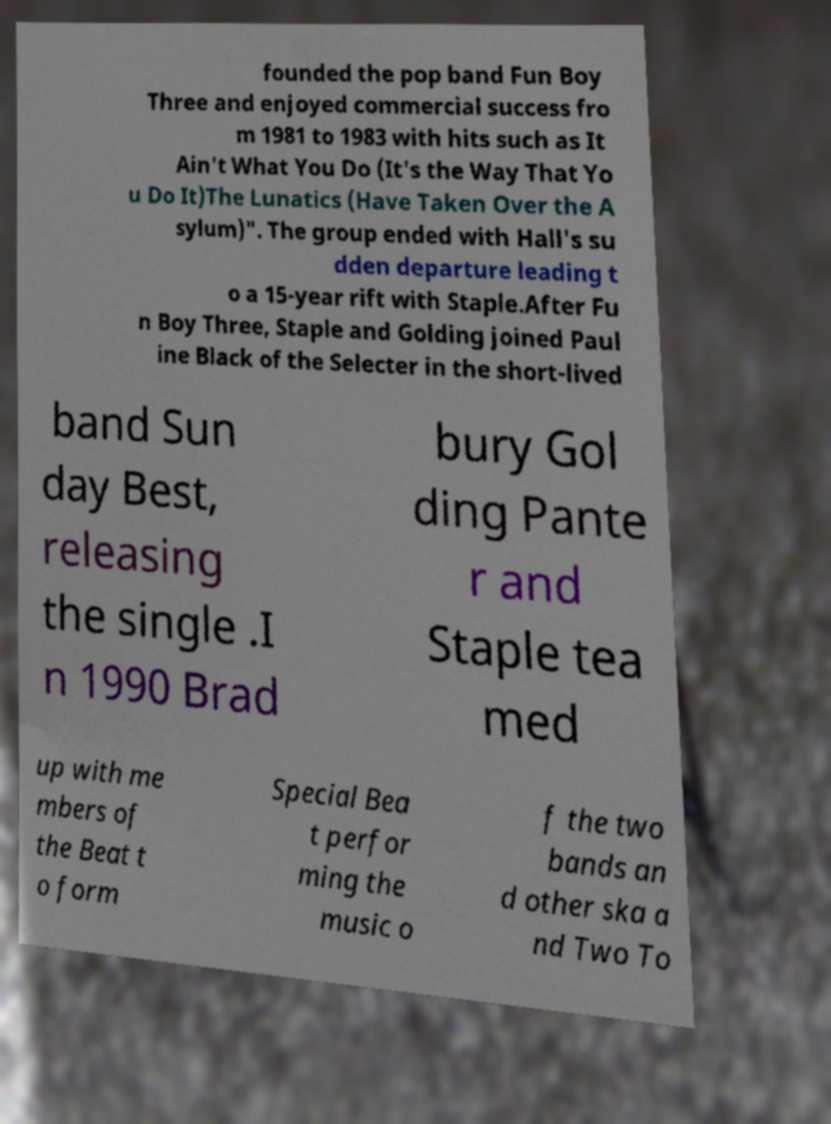Please identify and transcribe the text found in this image. founded the pop band Fun Boy Three and enjoyed commercial success fro m 1981 to 1983 with hits such as It Ain't What You Do (It's the Way That Yo u Do It)The Lunatics (Have Taken Over the A sylum)". The group ended with Hall's su dden departure leading t o a 15-year rift with Staple.After Fu n Boy Three, Staple and Golding joined Paul ine Black of the Selecter in the short-lived band Sun day Best, releasing the single .I n 1990 Brad bury Gol ding Pante r and Staple tea med up with me mbers of the Beat t o form Special Bea t perfor ming the music o f the two bands an d other ska a nd Two To 